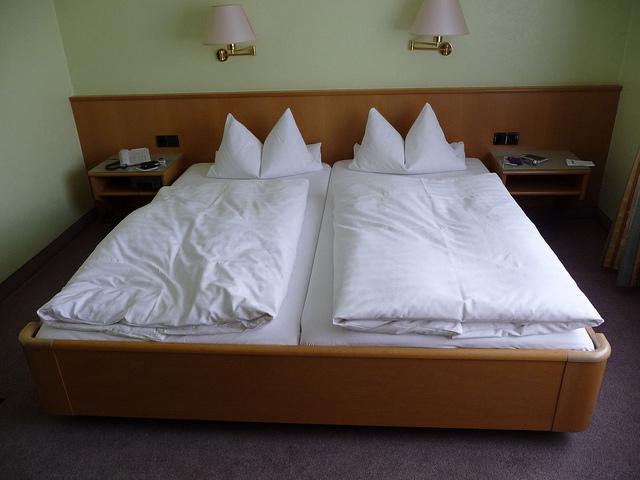Is this a hotel?
Be succinct. Yes. Could more than one person sleep comfortably on this bed?
Quick response, please. Yes. What color are the sheets?
Short answer required. White. 